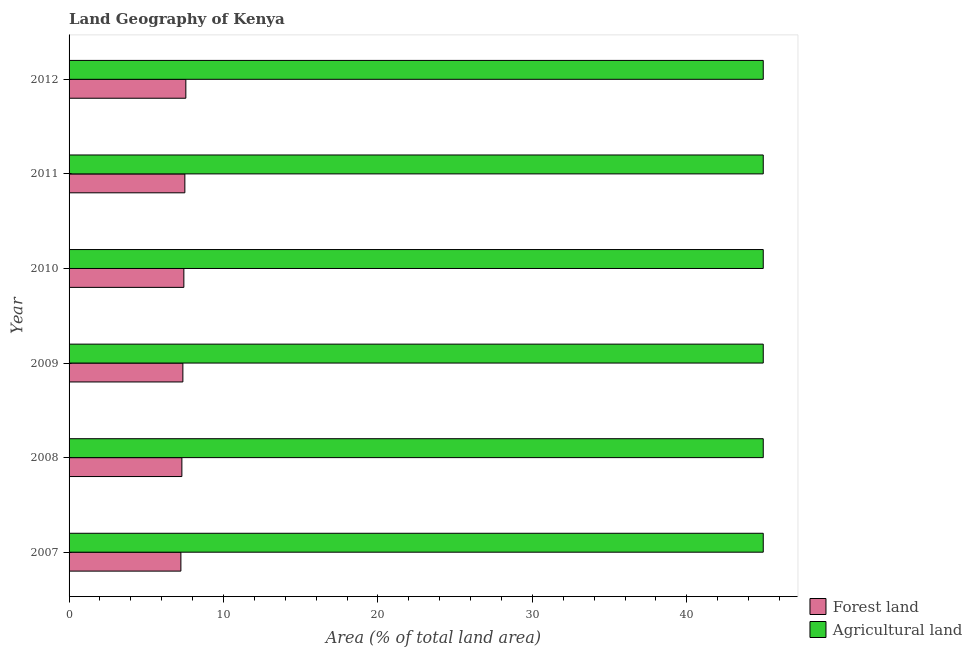How many groups of bars are there?
Offer a very short reply. 6. Are the number of bars on each tick of the Y-axis equal?
Provide a succinct answer. Yes. What is the label of the 3rd group of bars from the top?
Make the answer very short. 2010. In how many cases, is the number of bars for a given year not equal to the number of legend labels?
Make the answer very short. 0. What is the percentage of land area under forests in 2011?
Provide a short and direct response. 7.5. Across all years, what is the maximum percentage of land area under agriculture?
Your answer should be very brief. 44.95. Across all years, what is the minimum percentage of land area under forests?
Make the answer very short. 7.24. What is the total percentage of land area under agriculture in the graph?
Your response must be concise. 269.67. What is the difference between the percentage of land area under forests in 2007 and that in 2012?
Keep it short and to the point. -0.32. What is the difference between the percentage of land area under forests in 2011 and the percentage of land area under agriculture in 2010?
Your answer should be compact. -37.45. What is the average percentage of land area under forests per year?
Give a very brief answer. 7.4. In the year 2011, what is the difference between the percentage of land area under forests and percentage of land area under agriculture?
Your answer should be very brief. -37.45. Is the difference between the percentage of land area under forests in 2008 and 2010 greater than the difference between the percentage of land area under agriculture in 2008 and 2010?
Provide a short and direct response. No. What is the difference between the highest and the second highest percentage of land area under forests?
Your answer should be very brief. 0.06. In how many years, is the percentage of land area under agriculture greater than the average percentage of land area under agriculture taken over all years?
Provide a short and direct response. 6. Is the sum of the percentage of land area under agriculture in 2008 and 2009 greater than the maximum percentage of land area under forests across all years?
Provide a short and direct response. Yes. What does the 1st bar from the top in 2012 represents?
Your answer should be compact. Agricultural land. What does the 2nd bar from the bottom in 2009 represents?
Offer a very short reply. Agricultural land. Are all the bars in the graph horizontal?
Provide a short and direct response. Yes. What is the title of the graph?
Your response must be concise. Land Geography of Kenya. What is the label or title of the X-axis?
Keep it short and to the point. Area (% of total land area). What is the label or title of the Y-axis?
Make the answer very short. Year. What is the Area (% of total land area) of Forest land in 2007?
Your response must be concise. 7.24. What is the Area (% of total land area) of Agricultural land in 2007?
Provide a succinct answer. 44.95. What is the Area (% of total land area) of Forest land in 2008?
Keep it short and to the point. 7.3. What is the Area (% of total land area) in Agricultural land in 2008?
Make the answer very short. 44.95. What is the Area (% of total land area) of Forest land in 2009?
Provide a succinct answer. 7.37. What is the Area (% of total land area) of Agricultural land in 2009?
Make the answer very short. 44.95. What is the Area (% of total land area) of Forest land in 2010?
Provide a succinct answer. 7.43. What is the Area (% of total land area) of Agricultural land in 2010?
Offer a very short reply. 44.95. What is the Area (% of total land area) in Forest land in 2011?
Your response must be concise. 7.5. What is the Area (% of total land area) in Agricultural land in 2011?
Keep it short and to the point. 44.95. What is the Area (% of total land area) of Forest land in 2012?
Your answer should be compact. 7.56. What is the Area (% of total land area) in Agricultural land in 2012?
Your response must be concise. 44.95. Across all years, what is the maximum Area (% of total land area) in Forest land?
Offer a very short reply. 7.56. Across all years, what is the maximum Area (% of total land area) of Agricultural land?
Keep it short and to the point. 44.95. Across all years, what is the minimum Area (% of total land area) in Forest land?
Make the answer very short. 7.24. Across all years, what is the minimum Area (% of total land area) of Agricultural land?
Provide a succinct answer. 44.95. What is the total Area (% of total land area) of Forest land in the graph?
Keep it short and to the point. 44.4. What is the total Area (% of total land area) in Agricultural land in the graph?
Your response must be concise. 269.67. What is the difference between the Area (% of total land area) in Forest land in 2007 and that in 2008?
Offer a very short reply. -0.06. What is the difference between the Area (% of total land area) in Agricultural land in 2007 and that in 2008?
Offer a terse response. 0. What is the difference between the Area (% of total land area) in Forest land in 2007 and that in 2009?
Make the answer very short. -0.13. What is the difference between the Area (% of total land area) of Forest land in 2007 and that in 2010?
Ensure brevity in your answer.  -0.19. What is the difference between the Area (% of total land area) in Agricultural land in 2007 and that in 2010?
Ensure brevity in your answer.  0. What is the difference between the Area (% of total land area) of Forest land in 2007 and that in 2011?
Provide a short and direct response. -0.26. What is the difference between the Area (% of total land area) of Forest land in 2007 and that in 2012?
Make the answer very short. -0.32. What is the difference between the Area (% of total land area) of Forest land in 2008 and that in 2009?
Your response must be concise. -0.06. What is the difference between the Area (% of total land area) in Agricultural land in 2008 and that in 2009?
Make the answer very short. 0. What is the difference between the Area (% of total land area) in Forest land in 2008 and that in 2010?
Keep it short and to the point. -0.13. What is the difference between the Area (% of total land area) in Agricultural land in 2008 and that in 2010?
Offer a very short reply. 0. What is the difference between the Area (% of total land area) in Forest land in 2008 and that in 2011?
Offer a terse response. -0.19. What is the difference between the Area (% of total land area) in Forest land in 2008 and that in 2012?
Keep it short and to the point. -0.26. What is the difference between the Area (% of total land area) in Agricultural land in 2008 and that in 2012?
Keep it short and to the point. 0. What is the difference between the Area (% of total land area) of Forest land in 2009 and that in 2010?
Your answer should be very brief. -0.06. What is the difference between the Area (% of total land area) in Agricultural land in 2009 and that in 2010?
Your answer should be very brief. 0. What is the difference between the Area (% of total land area) in Forest land in 2009 and that in 2011?
Offer a very short reply. -0.13. What is the difference between the Area (% of total land area) of Agricultural land in 2009 and that in 2011?
Your answer should be very brief. 0. What is the difference between the Area (% of total land area) in Forest land in 2009 and that in 2012?
Make the answer very short. -0.19. What is the difference between the Area (% of total land area) in Agricultural land in 2009 and that in 2012?
Keep it short and to the point. 0. What is the difference between the Area (% of total land area) in Forest land in 2010 and that in 2011?
Offer a very short reply. -0.06. What is the difference between the Area (% of total land area) in Agricultural land in 2010 and that in 2011?
Your answer should be compact. 0. What is the difference between the Area (% of total land area) of Forest land in 2010 and that in 2012?
Offer a very short reply. -0.13. What is the difference between the Area (% of total land area) of Agricultural land in 2010 and that in 2012?
Give a very brief answer. 0. What is the difference between the Area (% of total land area) in Forest land in 2011 and that in 2012?
Make the answer very short. -0.06. What is the difference between the Area (% of total land area) of Agricultural land in 2011 and that in 2012?
Ensure brevity in your answer.  0. What is the difference between the Area (% of total land area) in Forest land in 2007 and the Area (% of total land area) in Agricultural land in 2008?
Provide a succinct answer. -37.71. What is the difference between the Area (% of total land area) of Forest land in 2007 and the Area (% of total land area) of Agricultural land in 2009?
Provide a short and direct response. -37.71. What is the difference between the Area (% of total land area) in Forest land in 2007 and the Area (% of total land area) in Agricultural land in 2010?
Offer a very short reply. -37.71. What is the difference between the Area (% of total land area) of Forest land in 2007 and the Area (% of total land area) of Agricultural land in 2011?
Provide a short and direct response. -37.71. What is the difference between the Area (% of total land area) of Forest land in 2007 and the Area (% of total land area) of Agricultural land in 2012?
Provide a short and direct response. -37.71. What is the difference between the Area (% of total land area) of Forest land in 2008 and the Area (% of total land area) of Agricultural land in 2009?
Provide a short and direct response. -37.64. What is the difference between the Area (% of total land area) in Forest land in 2008 and the Area (% of total land area) in Agricultural land in 2010?
Your response must be concise. -37.64. What is the difference between the Area (% of total land area) in Forest land in 2008 and the Area (% of total land area) in Agricultural land in 2011?
Your response must be concise. -37.64. What is the difference between the Area (% of total land area) in Forest land in 2008 and the Area (% of total land area) in Agricultural land in 2012?
Provide a succinct answer. -37.64. What is the difference between the Area (% of total land area) in Forest land in 2009 and the Area (% of total land area) in Agricultural land in 2010?
Offer a terse response. -37.58. What is the difference between the Area (% of total land area) of Forest land in 2009 and the Area (% of total land area) of Agricultural land in 2011?
Your response must be concise. -37.58. What is the difference between the Area (% of total land area) in Forest land in 2009 and the Area (% of total land area) in Agricultural land in 2012?
Ensure brevity in your answer.  -37.58. What is the difference between the Area (% of total land area) of Forest land in 2010 and the Area (% of total land area) of Agricultural land in 2011?
Give a very brief answer. -37.51. What is the difference between the Area (% of total land area) in Forest land in 2010 and the Area (% of total land area) in Agricultural land in 2012?
Your response must be concise. -37.51. What is the difference between the Area (% of total land area) of Forest land in 2011 and the Area (% of total land area) of Agricultural land in 2012?
Your response must be concise. -37.45. What is the average Area (% of total land area) of Forest land per year?
Make the answer very short. 7.4. What is the average Area (% of total land area) of Agricultural land per year?
Your response must be concise. 44.95. In the year 2007, what is the difference between the Area (% of total land area) in Forest land and Area (% of total land area) in Agricultural land?
Your answer should be compact. -37.71. In the year 2008, what is the difference between the Area (% of total land area) of Forest land and Area (% of total land area) of Agricultural land?
Keep it short and to the point. -37.64. In the year 2009, what is the difference between the Area (% of total land area) in Forest land and Area (% of total land area) in Agricultural land?
Offer a very short reply. -37.58. In the year 2010, what is the difference between the Area (% of total land area) of Forest land and Area (% of total land area) of Agricultural land?
Give a very brief answer. -37.51. In the year 2011, what is the difference between the Area (% of total land area) of Forest land and Area (% of total land area) of Agricultural land?
Offer a terse response. -37.45. In the year 2012, what is the difference between the Area (% of total land area) of Forest land and Area (% of total land area) of Agricultural land?
Keep it short and to the point. -37.38. What is the ratio of the Area (% of total land area) in Forest land in 2007 to that in 2009?
Your response must be concise. 0.98. What is the ratio of the Area (% of total land area) in Forest land in 2007 to that in 2011?
Your answer should be compact. 0.97. What is the ratio of the Area (% of total land area) in Forest land in 2007 to that in 2012?
Give a very brief answer. 0.96. What is the ratio of the Area (% of total land area) in Agricultural land in 2008 to that in 2009?
Give a very brief answer. 1. What is the ratio of the Area (% of total land area) in Forest land in 2008 to that in 2010?
Your answer should be very brief. 0.98. What is the ratio of the Area (% of total land area) of Forest land in 2008 to that in 2011?
Provide a short and direct response. 0.97. What is the ratio of the Area (% of total land area) of Agricultural land in 2008 to that in 2012?
Offer a very short reply. 1. What is the ratio of the Area (% of total land area) in Forest land in 2009 to that in 2011?
Offer a terse response. 0.98. What is the ratio of the Area (% of total land area) in Agricultural land in 2009 to that in 2011?
Keep it short and to the point. 1. What is the ratio of the Area (% of total land area) in Forest land in 2009 to that in 2012?
Offer a terse response. 0.97. What is the ratio of the Area (% of total land area) in Agricultural land in 2009 to that in 2012?
Ensure brevity in your answer.  1. What is the ratio of the Area (% of total land area) of Forest land in 2010 to that in 2012?
Provide a short and direct response. 0.98. What is the ratio of the Area (% of total land area) in Agricultural land in 2010 to that in 2012?
Your answer should be compact. 1. What is the ratio of the Area (% of total land area) of Forest land in 2011 to that in 2012?
Offer a terse response. 0.99. What is the difference between the highest and the second highest Area (% of total land area) in Forest land?
Your answer should be compact. 0.06. What is the difference between the highest and the lowest Area (% of total land area) of Forest land?
Make the answer very short. 0.32. What is the difference between the highest and the lowest Area (% of total land area) of Agricultural land?
Make the answer very short. 0. 